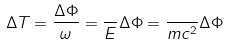<formula> <loc_0><loc_0><loc_500><loc_500>\Delta T = \frac { \Delta \Phi } { \omega } = \frac { } { E } \Delta \Phi = \frac { } { m c ^ { 2 } } \Delta \Phi</formula> 